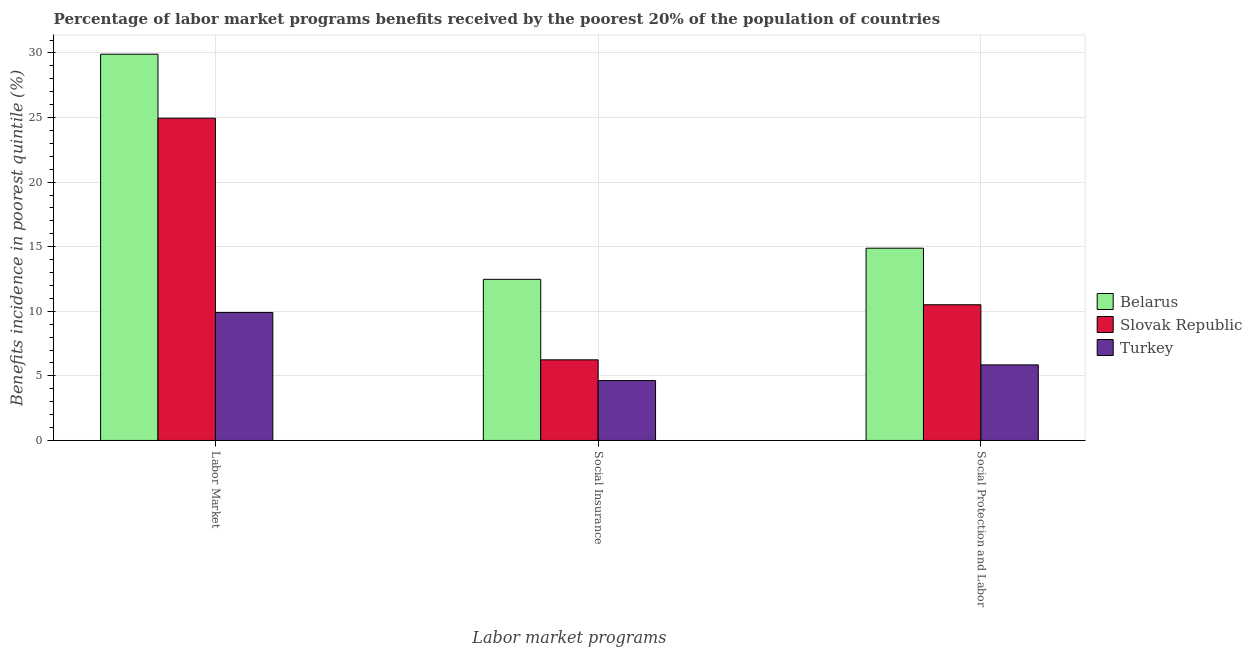How many groups of bars are there?
Keep it short and to the point. 3. Are the number of bars per tick equal to the number of legend labels?
Provide a succinct answer. Yes. Are the number of bars on each tick of the X-axis equal?
Make the answer very short. Yes. How many bars are there on the 1st tick from the left?
Your answer should be compact. 3. What is the label of the 1st group of bars from the left?
Your response must be concise. Labor Market. What is the percentage of benefits received due to social insurance programs in Slovak Republic?
Provide a succinct answer. 6.24. Across all countries, what is the maximum percentage of benefits received due to social insurance programs?
Give a very brief answer. 12.47. Across all countries, what is the minimum percentage of benefits received due to social protection programs?
Your response must be concise. 5.85. In which country was the percentage of benefits received due to labor market programs maximum?
Make the answer very short. Belarus. In which country was the percentage of benefits received due to social protection programs minimum?
Keep it short and to the point. Turkey. What is the total percentage of benefits received due to labor market programs in the graph?
Your answer should be very brief. 64.76. What is the difference between the percentage of benefits received due to social insurance programs in Slovak Republic and that in Turkey?
Keep it short and to the point. 1.6. What is the difference between the percentage of benefits received due to social protection programs in Turkey and the percentage of benefits received due to social insurance programs in Belarus?
Offer a very short reply. -6.62. What is the average percentage of benefits received due to labor market programs per country?
Your response must be concise. 21.59. What is the difference between the percentage of benefits received due to labor market programs and percentage of benefits received due to social insurance programs in Turkey?
Provide a succinct answer. 5.27. What is the ratio of the percentage of benefits received due to labor market programs in Belarus to that in Turkey?
Your answer should be compact. 3.02. Is the difference between the percentage of benefits received due to labor market programs in Slovak Republic and Turkey greater than the difference between the percentage of benefits received due to social insurance programs in Slovak Republic and Turkey?
Make the answer very short. Yes. What is the difference between the highest and the second highest percentage of benefits received due to labor market programs?
Provide a short and direct response. 4.96. What is the difference between the highest and the lowest percentage of benefits received due to labor market programs?
Keep it short and to the point. 20. In how many countries, is the percentage of benefits received due to social insurance programs greater than the average percentage of benefits received due to social insurance programs taken over all countries?
Provide a succinct answer. 1. What does the 2nd bar from the left in Social Protection and Labor represents?
Your answer should be very brief. Slovak Republic. What does the 1st bar from the right in Social Protection and Labor represents?
Provide a succinct answer. Turkey. How many bars are there?
Offer a terse response. 9. How many countries are there in the graph?
Offer a terse response. 3. Are the values on the major ticks of Y-axis written in scientific E-notation?
Give a very brief answer. No. Does the graph contain any zero values?
Offer a terse response. No. How many legend labels are there?
Make the answer very short. 3. How are the legend labels stacked?
Offer a terse response. Vertical. What is the title of the graph?
Give a very brief answer. Percentage of labor market programs benefits received by the poorest 20% of the population of countries. Does "Dominican Republic" appear as one of the legend labels in the graph?
Offer a terse response. No. What is the label or title of the X-axis?
Your answer should be very brief. Labor market programs. What is the label or title of the Y-axis?
Make the answer very short. Benefits incidence in poorest quintile (%). What is the Benefits incidence in poorest quintile (%) of Belarus in Labor Market?
Make the answer very short. 29.9. What is the Benefits incidence in poorest quintile (%) in Slovak Republic in Labor Market?
Your answer should be compact. 24.95. What is the Benefits incidence in poorest quintile (%) of Turkey in Labor Market?
Provide a succinct answer. 9.91. What is the Benefits incidence in poorest quintile (%) of Belarus in Social Insurance?
Ensure brevity in your answer.  12.47. What is the Benefits incidence in poorest quintile (%) in Slovak Republic in Social Insurance?
Provide a succinct answer. 6.24. What is the Benefits incidence in poorest quintile (%) of Turkey in Social Insurance?
Offer a terse response. 4.64. What is the Benefits incidence in poorest quintile (%) of Belarus in Social Protection and Labor?
Give a very brief answer. 14.89. What is the Benefits incidence in poorest quintile (%) of Slovak Republic in Social Protection and Labor?
Keep it short and to the point. 10.5. What is the Benefits incidence in poorest quintile (%) in Turkey in Social Protection and Labor?
Provide a succinct answer. 5.85. Across all Labor market programs, what is the maximum Benefits incidence in poorest quintile (%) of Belarus?
Ensure brevity in your answer.  29.9. Across all Labor market programs, what is the maximum Benefits incidence in poorest quintile (%) in Slovak Republic?
Give a very brief answer. 24.95. Across all Labor market programs, what is the maximum Benefits incidence in poorest quintile (%) in Turkey?
Your response must be concise. 9.91. Across all Labor market programs, what is the minimum Benefits incidence in poorest quintile (%) of Belarus?
Offer a terse response. 12.47. Across all Labor market programs, what is the minimum Benefits incidence in poorest quintile (%) in Slovak Republic?
Your answer should be very brief. 6.24. Across all Labor market programs, what is the minimum Benefits incidence in poorest quintile (%) in Turkey?
Your answer should be compact. 4.64. What is the total Benefits incidence in poorest quintile (%) of Belarus in the graph?
Your answer should be very brief. 57.26. What is the total Benefits incidence in poorest quintile (%) of Slovak Republic in the graph?
Your response must be concise. 41.7. What is the total Benefits incidence in poorest quintile (%) in Turkey in the graph?
Your answer should be very brief. 20.4. What is the difference between the Benefits incidence in poorest quintile (%) in Belarus in Labor Market and that in Social Insurance?
Your answer should be very brief. 17.43. What is the difference between the Benefits incidence in poorest quintile (%) of Slovak Republic in Labor Market and that in Social Insurance?
Your answer should be compact. 18.71. What is the difference between the Benefits incidence in poorest quintile (%) of Turkey in Labor Market and that in Social Insurance?
Ensure brevity in your answer.  5.27. What is the difference between the Benefits incidence in poorest quintile (%) in Belarus in Labor Market and that in Social Protection and Labor?
Provide a short and direct response. 15.02. What is the difference between the Benefits incidence in poorest quintile (%) of Slovak Republic in Labor Market and that in Social Protection and Labor?
Offer a very short reply. 14.44. What is the difference between the Benefits incidence in poorest quintile (%) of Turkey in Labor Market and that in Social Protection and Labor?
Offer a very short reply. 4.06. What is the difference between the Benefits incidence in poorest quintile (%) in Belarus in Social Insurance and that in Social Protection and Labor?
Ensure brevity in your answer.  -2.41. What is the difference between the Benefits incidence in poorest quintile (%) of Slovak Republic in Social Insurance and that in Social Protection and Labor?
Make the answer very short. -4.26. What is the difference between the Benefits incidence in poorest quintile (%) in Turkey in Social Insurance and that in Social Protection and Labor?
Ensure brevity in your answer.  -1.21. What is the difference between the Benefits incidence in poorest quintile (%) of Belarus in Labor Market and the Benefits incidence in poorest quintile (%) of Slovak Republic in Social Insurance?
Provide a short and direct response. 23.66. What is the difference between the Benefits incidence in poorest quintile (%) in Belarus in Labor Market and the Benefits incidence in poorest quintile (%) in Turkey in Social Insurance?
Your answer should be very brief. 25.27. What is the difference between the Benefits incidence in poorest quintile (%) in Slovak Republic in Labor Market and the Benefits incidence in poorest quintile (%) in Turkey in Social Insurance?
Ensure brevity in your answer.  20.31. What is the difference between the Benefits incidence in poorest quintile (%) in Belarus in Labor Market and the Benefits incidence in poorest quintile (%) in Slovak Republic in Social Protection and Labor?
Your response must be concise. 19.4. What is the difference between the Benefits incidence in poorest quintile (%) of Belarus in Labor Market and the Benefits incidence in poorest quintile (%) of Turkey in Social Protection and Labor?
Make the answer very short. 24.05. What is the difference between the Benefits incidence in poorest quintile (%) in Slovak Republic in Labor Market and the Benefits incidence in poorest quintile (%) in Turkey in Social Protection and Labor?
Provide a short and direct response. 19.1. What is the difference between the Benefits incidence in poorest quintile (%) in Belarus in Social Insurance and the Benefits incidence in poorest quintile (%) in Slovak Republic in Social Protection and Labor?
Offer a terse response. 1.97. What is the difference between the Benefits incidence in poorest quintile (%) in Belarus in Social Insurance and the Benefits incidence in poorest quintile (%) in Turkey in Social Protection and Labor?
Give a very brief answer. 6.62. What is the difference between the Benefits incidence in poorest quintile (%) of Slovak Republic in Social Insurance and the Benefits incidence in poorest quintile (%) of Turkey in Social Protection and Labor?
Ensure brevity in your answer.  0.39. What is the average Benefits incidence in poorest quintile (%) of Belarus per Labor market programs?
Keep it short and to the point. 19.09. What is the average Benefits incidence in poorest quintile (%) in Slovak Republic per Labor market programs?
Provide a succinct answer. 13.9. What is the average Benefits incidence in poorest quintile (%) of Turkey per Labor market programs?
Your response must be concise. 6.8. What is the difference between the Benefits incidence in poorest quintile (%) of Belarus and Benefits incidence in poorest quintile (%) of Slovak Republic in Labor Market?
Your answer should be compact. 4.96. What is the difference between the Benefits incidence in poorest quintile (%) in Belarus and Benefits incidence in poorest quintile (%) in Turkey in Labor Market?
Your answer should be very brief. 20. What is the difference between the Benefits incidence in poorest quintile (%) in Slovak Republic and Benefits incidence in poorest quintile (%) in Turkey in Labor Market?
Give a very brief answer. 15.04. What is the difference between the Benefits incidence in poorest quintile (%) in Belarus and Benefits incidence in poorest quintile (%) in Slovak Republic in Social Insurance?
Give a very brief answer. 6.23. What is the difference between the Benefits incidence in poorest quintile (%) in Belarus and Benefits incidence in poorest quintile (%) in Turkey in Social Insurance?
Give a very brief answer. 7.84. What is the difference between the Benefits incidence in poorest quintile (%) of Slovak Republic and Benefits incidence in poorest quintile (%) of Turkey in Social Insurance?
Your answer should be very brief. 1.6. What is the difference between the Benefits incidence in poorest quintile (%) in Belarus and Benefits incidence in poorest quintile (%) in Slovak Republic in Social Protection and Labor?
Give a very brief answer. 4.38. What is the difference between the Benefits incidence in poorest quintile (%) of Belarus and Benefits incidence in poorest quintile (%) of Turkey in Social Protection and Labor?
Offer a terse response. 9.03. What is the difference between the Benefits incidence in poorest quintile (%) of Slovak Republic and Benefits incidence in poorest quintile (%) of Turkey in Social Protection and Labor?
Offer a terse response. 4.65. What is the ratio of the Benefits incidence in poorest quintile (%) of Belarus in Labor Market to that in Social Insurance?
Provide a short and direct response. 2.4. What is the ratio of the Benefits incidence in poorest quintile (%) of Slovak Republic in Labor Market to that in Social Insurance?
Ensure brevity in your answer.  4. What is the ratio of the Benefits incidence in poorest quintile (%) in Turkey in Labor Market to that in Social Insurance?
Provide a succinct answer. 2.14. What is the ratio of the Benefits incidence in poorest quintile (%) in Belarus in Labor Market to that in Social Protection and Labor?
Offer a terse response. 2.01. What is the ratio of the Benefits incidence in poorest quintile (%) of Slovak Republic in Labor Market to that in Social Protection and Labor?
Offer a terse response. 2.38. What is the ratio of the Benefits incidence in poorest quintile (%) in Turkey in Labor Market to that in Social Protection and Labor?
Your answer should be compact. 1.69. What is the ratio of the Benefits incidence in poorest quintile (%) in Belarus in Social Insurance to that in Social Protection and Labor?
Make the answer very short. 0.84. What is the ratio of the Benefits incidence in poorest quintile (%) in Slovak Republic in Social Insurance to that in Social Protection and Labor?
Provide a succinct answer. 0.59. What is the ratio of the Benefits incidence in poorest quintile (%) of Turkey in Social Insurance to that in Social Protection and Labor?
Your answer should be very brief. 0.79. What is the difference between the highest and the second highest Benefits incidence in poorest quintile (%) in Belarus?
Your response must be concise. 15.02. What is the difference between the highest and the second highest Benefits incidence in poorest quintile (%) in Slovak Republic?
Keep it short and to the point. 14.44. What is the difference between the highest and the second highest Benefits incidence in poorest quintile (%) of Turkey?
Keep it short and to the point. 4.06. What is the difference between the highest and the lowest Benefits incidence in poorest quintile (%) of Belarus?
Give a very brief answer. 17.43. What is the difference between the highest and the lowest Benefits incidence in poorest quintile (%) of Slovak Republic?
Provide a short and direct response. 18.71. What is the difference between the highest and the lowest Benefits incidence in poorest quintile (%) of Turkey?
Give a very brief answer. 5.27. 